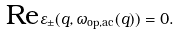<formula> <loc_0><loc_0><loc_500><loc_500>\text {Re} \varepsilon _ { \pm } ( q , \omega _ { \text {op,ac} } ( q ) ) = 0 .</formula> 